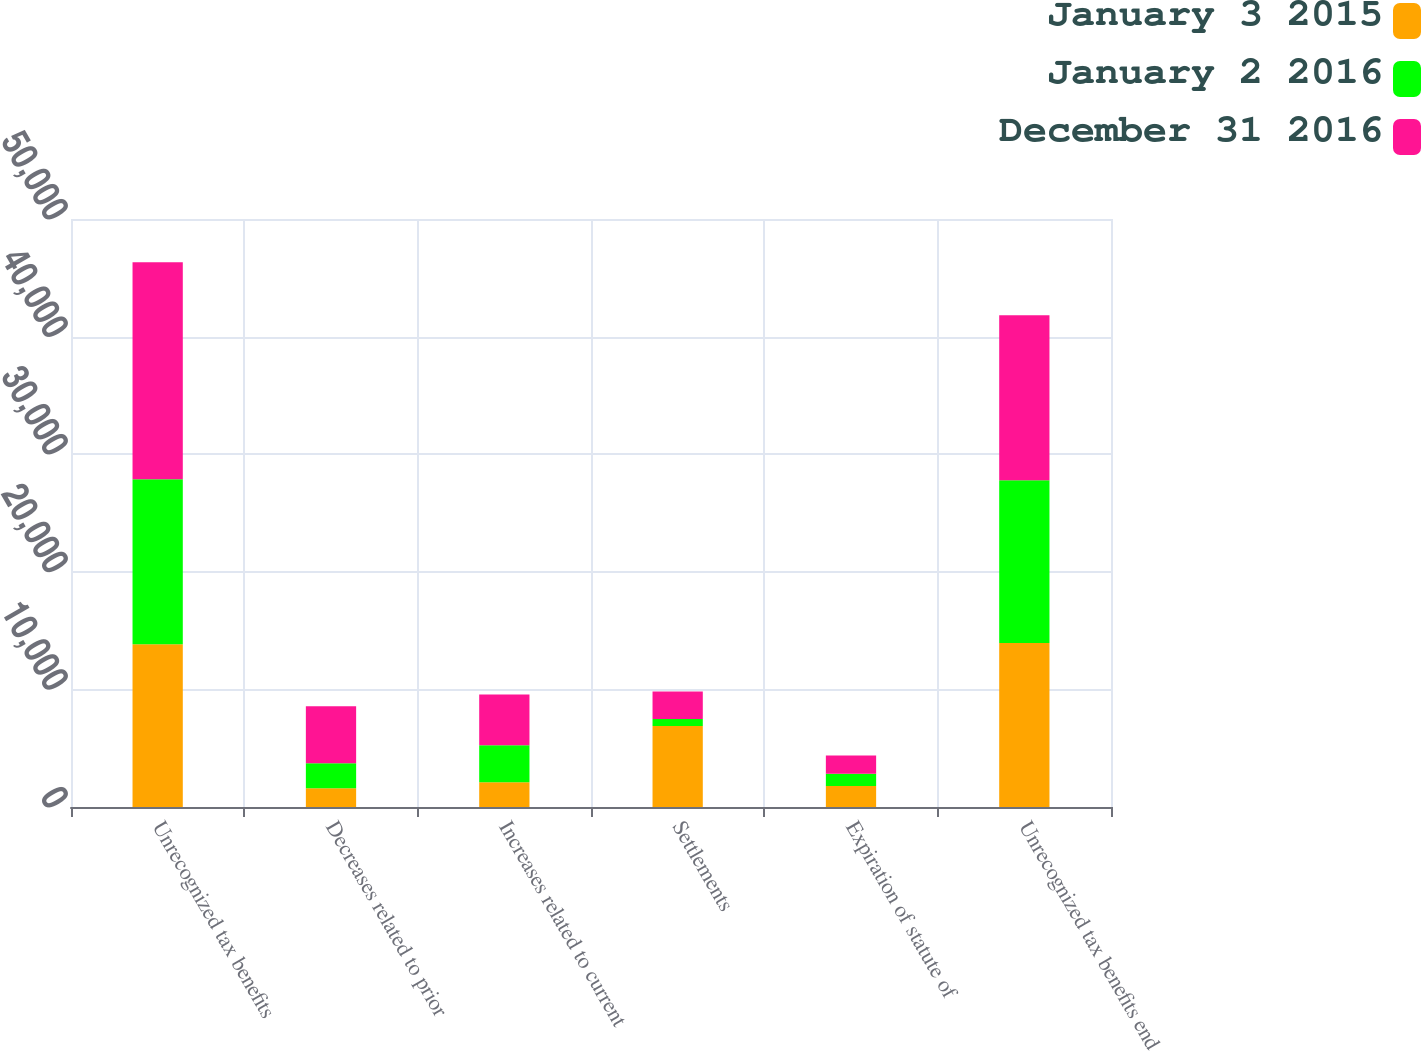Convert chart. <chart><loc_0><loc_0><loc_500><loc_500><stacked_bar_chart><ecel><fcel>Unrecognized tax benefits<fcel>Decreases related to prior<fcel>Increases related to current<fcel>Settlements<fcel>Expiration of statute of<fcel>Unrecognized tax benefits end<nl><fcel>January 3 2015<fcel>13841<fcel>1600<fcel>2105<fcel>6894<fcel>1780<fcel>13946<nl><fcel>January 2 2016<fcel>14033<fcel>2120<fcel>3137<fcel>582<fcel>1039<fcel>13841<nl><fcel>December 31 2016<fcel>18458<fcel>4841<fcel>4329<fcel>2345<fcel>1568<fcel>14033<nl></chart> 